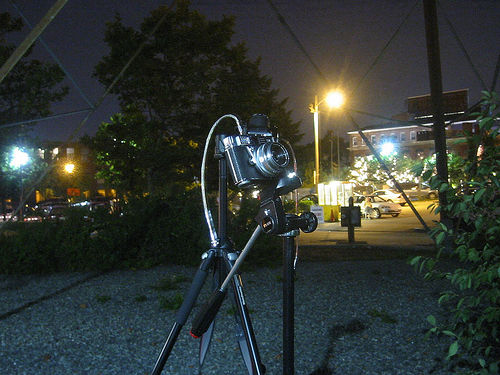<image>
Can you confirm if the tree is in front of the camera? No. The tree is not in front of the camera. The spatial positioning shows a different relationship between these objects. 